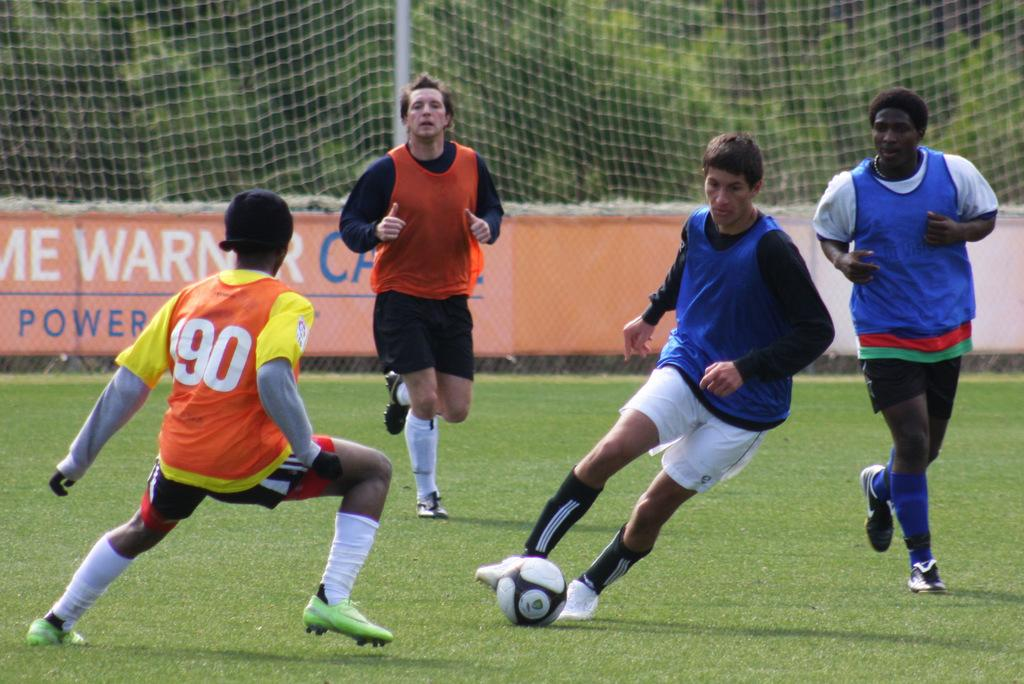<image>
Write a terse but informative summary of the picture. The player in the orange wears the number 90 vest. 